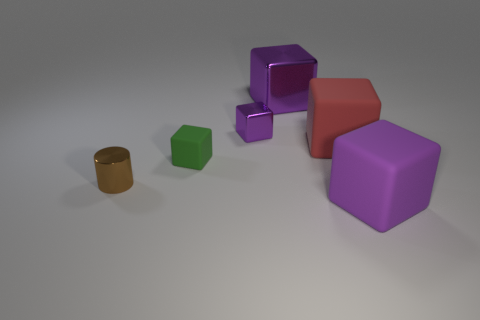Is there anything else that is the same size as the brown metallic cylinder?
Keep it short and to the point. Yes. What number of small yellow objects are there?
Your response must be concise. 0. What number of objects are made of the same material as the small green cube?
Provide a short and direct response. 2. How many things are either objects in front of the large metallic cube or large purple metallic things?
Give a very brief answer. 6. Is the number of tiny metal objects that are behind the cylinder less than the number of purple things right of the tiny green thing?
Give a very brief answer. Yes. Are there any things left of the big purple rubber object?
Give a very brief answer. Yes. What number of objects are either matte things that are to the right of the large shiny cube or big objects that are in front of the red thing?
Make the answer very short. 2. What number of other large things are the same color as the large metal object?
Give a very brief answer. 1. There is another large rubber thing that is the same shape as the purple matte object; what is its color?
Provide a succinct answer. Red. There is a object that is on the right side of the big metal object and behind the brown shiny cylinder; what shape is it?
Keep it short and to the point. Cube. 